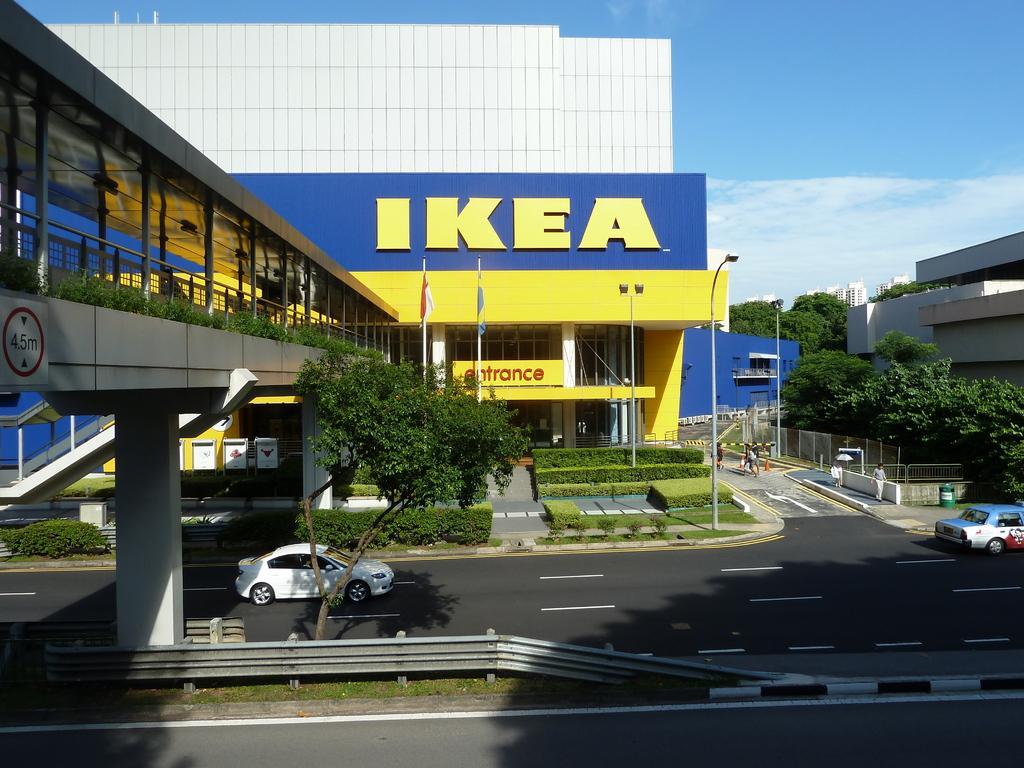Describe this image in one or two sentences. In this image I see the road over here on which there are cars and I see few people over here and I see the bushes and flags over here and I can also see a bridge and I see the light poles. In the background I see number of buildings, trees and I see the sky. 